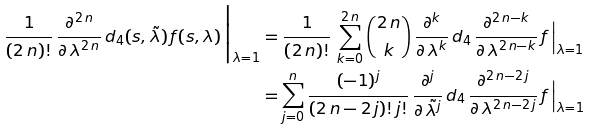Convert formula to latex. <formula><loc_0><loc_0><loc_500><loc_500>\frac { 1 } { ( 2 \, n ) ! } \, \frac { \partial ^ { 2 \, n } } { \partial \, \lambda ^ { 2 \, n } } \, d _ { 4 } ( s , \tilde { \lambda } ) \, f ( s , \lambda ) \, \Big { | } _ { \lambda = 1 } & = \frac { 1 } { ( 2 \, n ) ! } \, \sum _ { k = 0 } ^ { 2 \, n } \binom { 2 \, n } { k } \, \frac { \partial ^ { k } } { \partial \, \lambda ^ { k } } \, d _ { 4 \, } \frac { \partial ^ { 2 \, n - k } } { \partial \, \lambda ^ { 2 \, n - k } } \, f \, \Big { | } _ { \lambda = 1 } \\ & = \sum _ { j = 0 } ^ { n } \frac { ( - 1 ) ^ { j } } { ( 2 \, n - 2 \, j ) ! \, j ! } \, \frac { \partial ^ { j } } { \partial \, \tilde { \lambda } ^ { j } } \, d _ { 4 \, } \frac { \partial ^ { 2 \, n - 2 \, j } } { \partial \, \lambda ^ { 2 \, n - 2 \, j } } \, f \, \Big { | } _ { \lambda = 1 }</formula> 